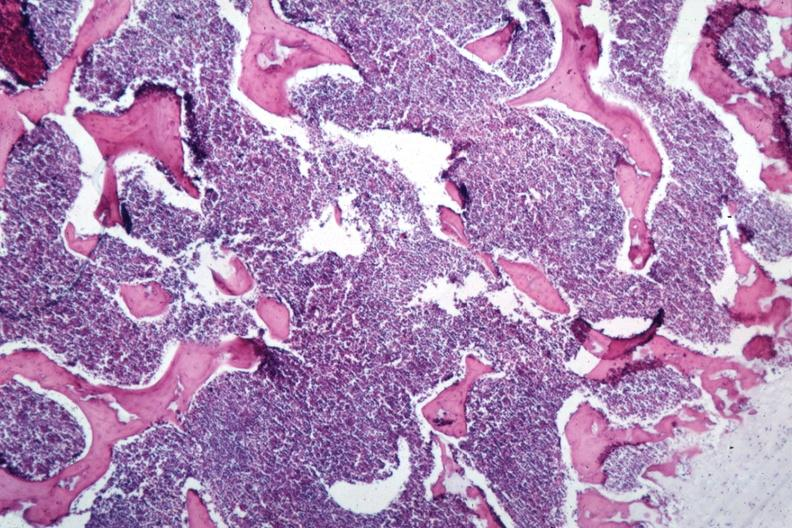s size present?
Answer the question using a single word or phrase. No 